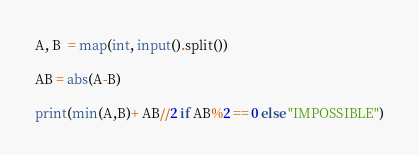<code> <loc_0><loc_0><loc_500><loc_500><_Python_>A, B  = map(int, input().split())

AB = abs(A-B)

print(min(A,B)+ AB//2 if AB%2 == 0 else "IMPOSSIBLE")</code> 